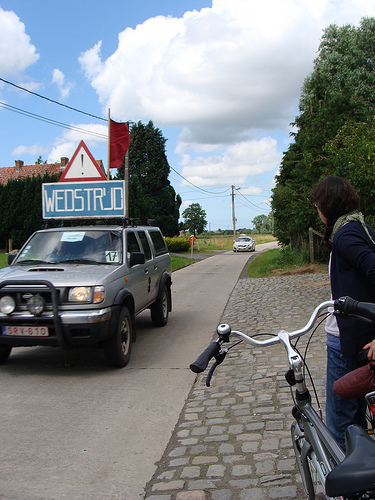<image>
Is the car to the left of the bike? Yes. From this viewpoint, the car is positioned to the left side relative to the bike. 